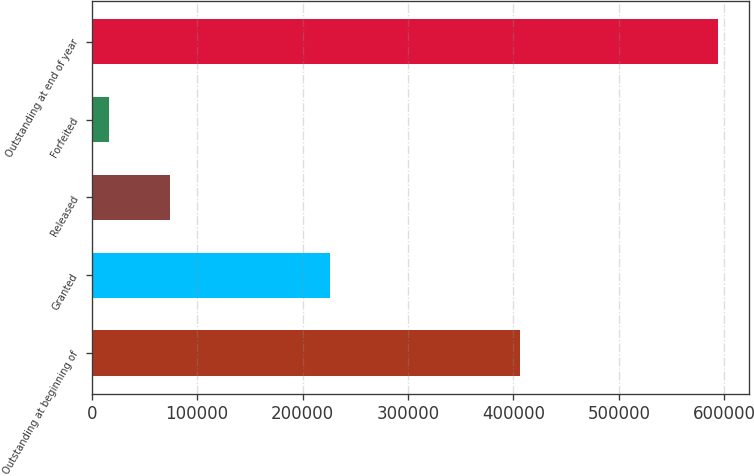Convert chart to OTSL. <chart><loc_0><loc_0><loc_500><loc_500><bar_chart><fcel>Outstanding at beginning of<fcel>Granted<fcel>Released<fcel>Forfeited<fcel>Outstanding at end of year<nl><fcel>406682<fcel>225985<fcel>74035.8<fcel>16252<fcel>594090<nl></chart> 